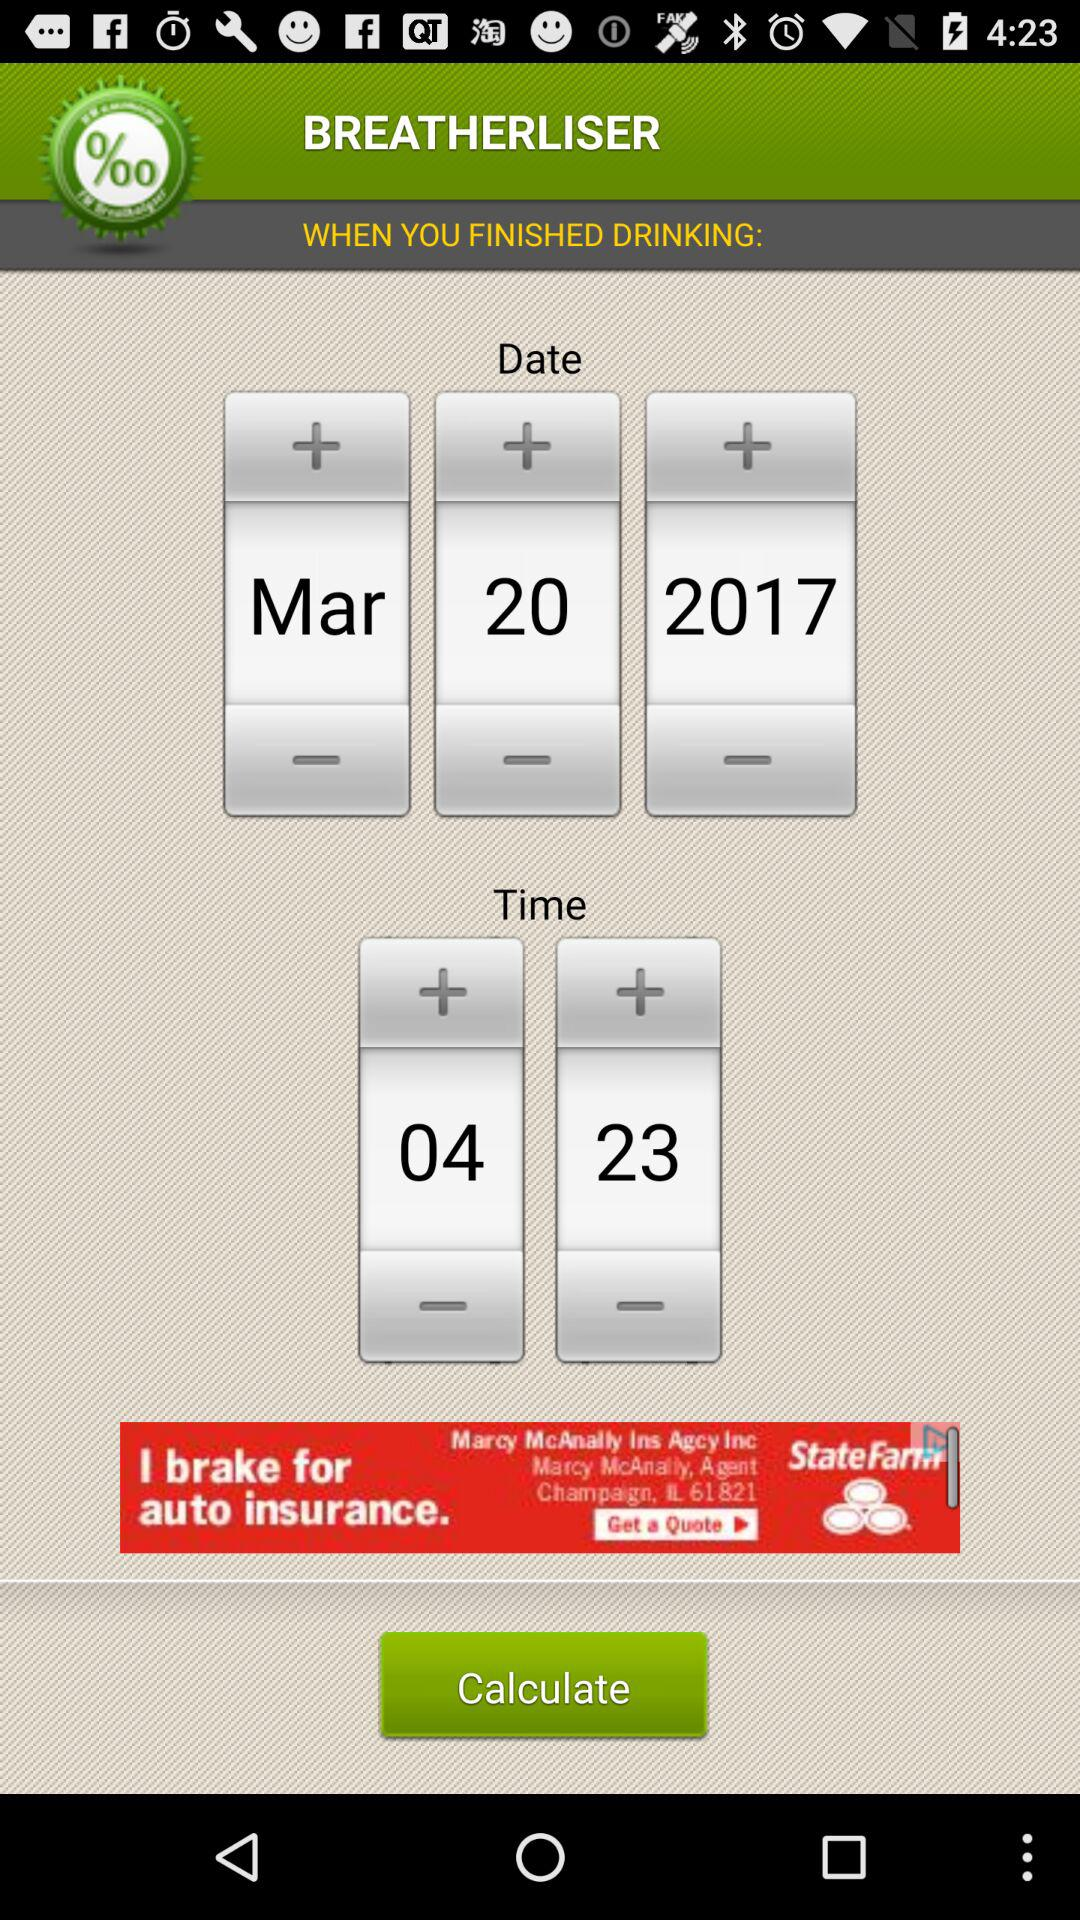What is the application name? The application name is "BREATHERLISER". 